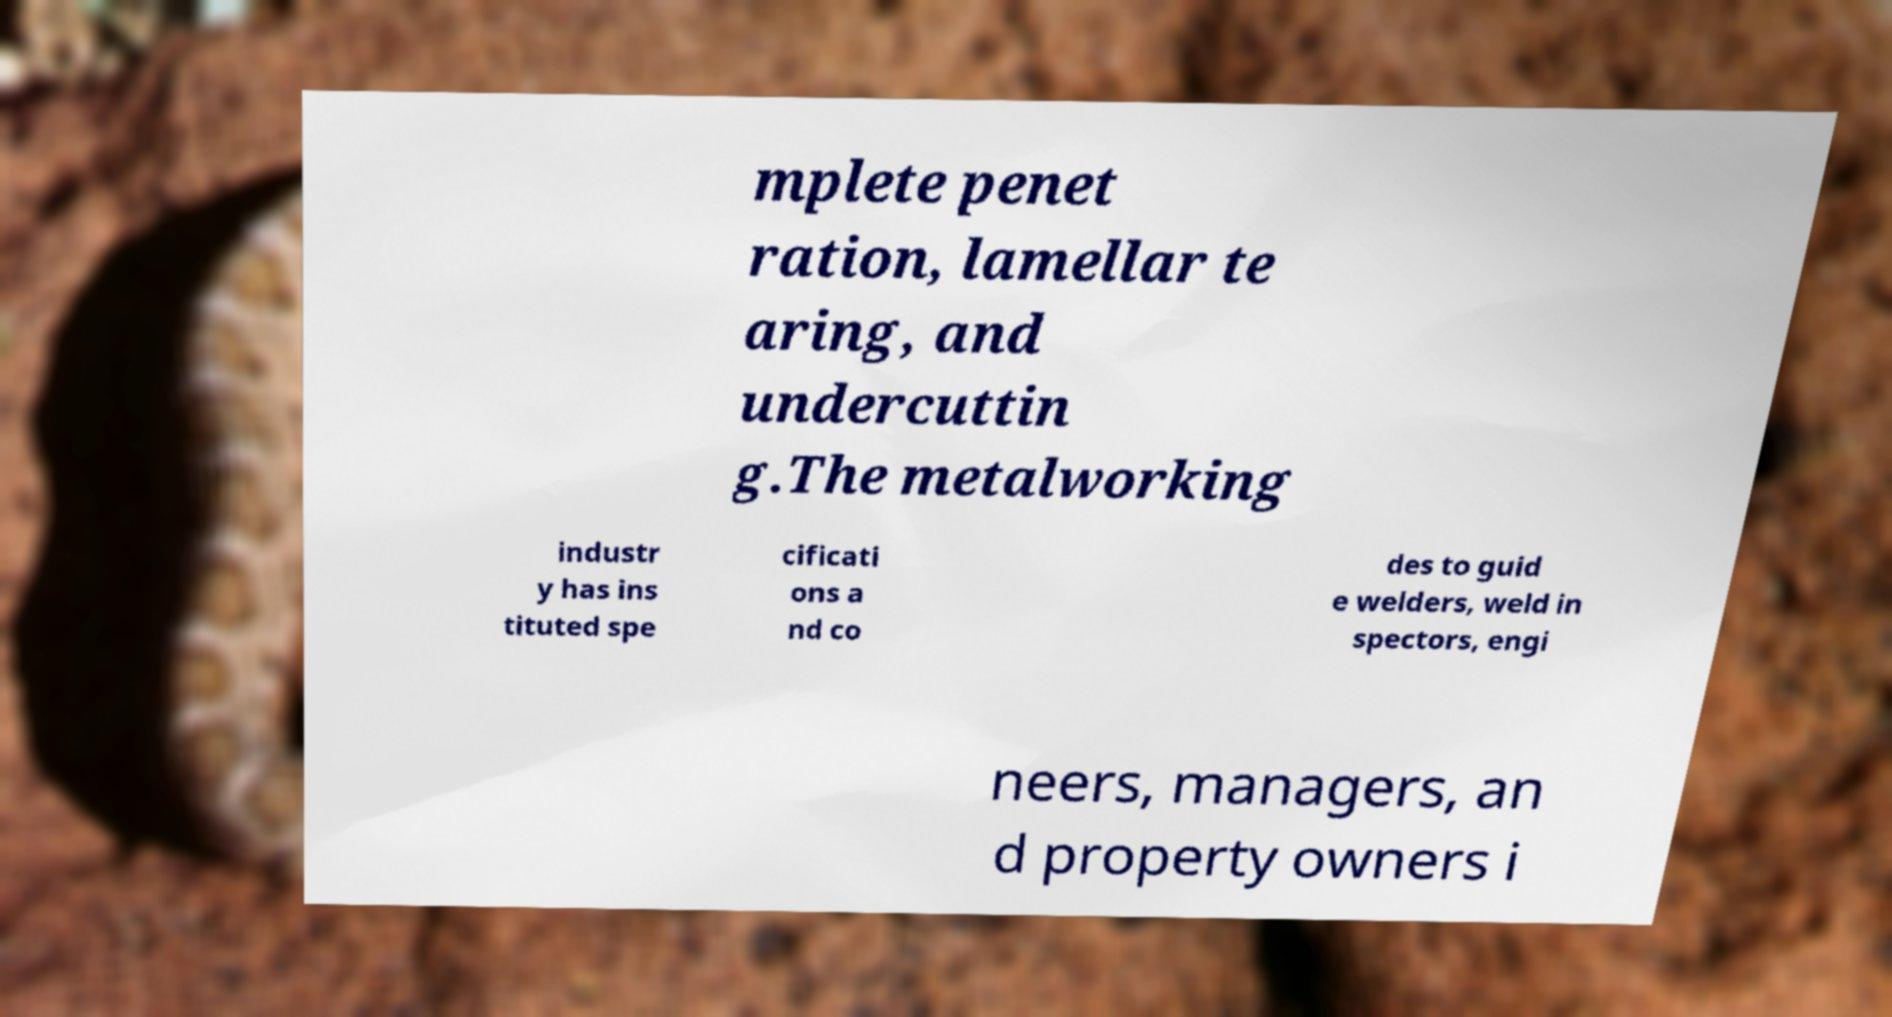Could you extract and type out the text from this image? mplete penet ration, lamellar te aring, and undercuttin g.The metalworking industr y has ins tituted spe cificati ons a nd co des to guid e welders, weld in spectors, engi neers, managers, an d property owners i 